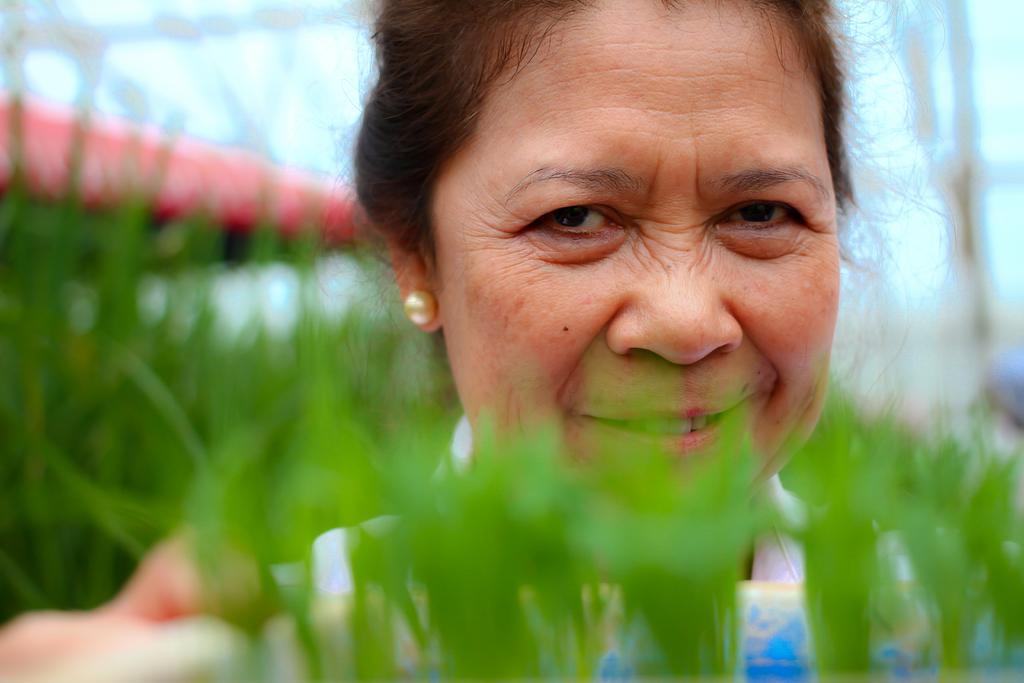Please provide a concise description of this image. There are plants near an object. In the background, there is a woman smiling, there are plants, there is a roof and there is sky. 